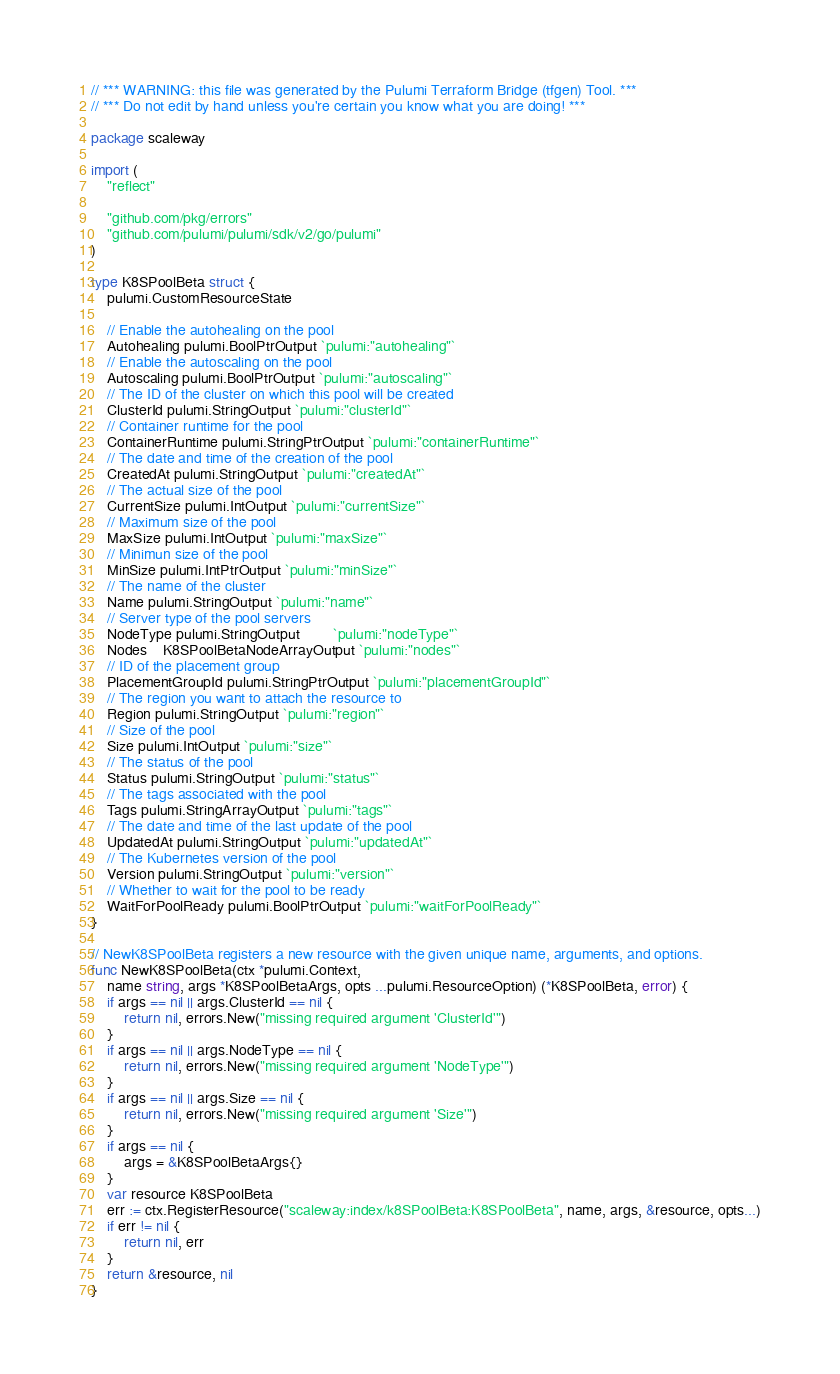Convert code to text. <code><loc_0><loc_0><loc_500><loc_500><_Go_>// *** WARNING: this file was generated by the Pulumi Terraform Bridge (tfgen) Tool. ***
// *** Do not edit by hand unless you're certain you know what you are doing! ***

package scaleway

import (
	"reflect"

	"github.com/pkg/errors"
	"github.com/pulumi/pulumi/sdk/v2/go/pulumi"
)

type K8SPoolBeta struct {
	pulumi.CustomResourceState

	// Enable the autohealing on the pool
	Autohealing pulumi.BoolPtrOutput `pulumi:"autohealing"`
	// Enable the autoscaling on the pool
	Autoscaling pulumi.BoolPtrOutput `pulumi:"autoscaling"`
	// The ID of the cluster on which this pool will be created
	ClusterId pulumi.StringOutput `pulumi:"clusterId"`
	// Container runtime for the pool
	ContainerRuntime pulumi.StringPtrOutput `pulumi:"containerRuntime"`
	// The date and time of the creation of the pool
	CreatedAt pulumi.StringOutput `pulumi:"createdAt"`
	// The actual size of the pool
	CurrentSize pulumi.IntOutput `pulumi:"currentSize"`
	// Maximum size of the pool
	MaxSize pulumi.IntOutput `pulumi:"maxSize"`
	// Minimun size of the pool
	MinSize pulumi.IntPtrOutput `pulumi:"minSize"`
	// The name of the cluster
	Name pulumi.StringOutput `pulumi:"name"`
	// Server type of the pool servers
	NodeType pulumi.StringOutput        `pulumi:"nodeType"`
	Nodes    K8SPoolBetaNodeArrayOutput `pulumi:"nodes"`
	// ID of the placement group
	PlacementGroupId pulumi.StringPtrOutput `pulumi:"placementGroupId"`
	// The region you want to attach the resource to
	Region pulumi.StringOutput `pulumi:"region"`
	// Size of the pool
	Size pulumi.IntOutput `pulumi:"size"`
	// The status of the pool
	Status pulumi.StringOutput `pulumi:"status"`
	// The tags associated with the pool
	Tags pulumi.StringArrayOutput `pulumi:"tags"`
	// The date and time of the last update of the pool
	UpdatedAt pulumi.StringOutput `pulumi:"updatedAt"`
	// The Kubernetes version of the pool
	Version pulumi.StringOutput `pulumi:"version"`
	// Whether to wait for the pool to be ready
	WaitForPoolReady pulumi.BoolPtrOutput `pulumi:"waitForPoolReady"`
}

// NewK8SPoolBeta registers a new resource with the given unique name, arguments, and options.
func NewK8SPoolBeta(ctx *pulumi.Context,
	name string, args *K8SPoolBetaArgs, opts ...pulumi.ResourceOption) (*K8SPoolBeta, error) {
	if args == nil || args.ClusterId == nil {
		return nil, errors.New("missing required argument 'ClusterId'")
	}
	if args == nil || args.NodeType == nil {
		return nil, errors.New("missing required argument 'NodeType'")
	}
	if args == nil || args.Size == nil {
		return nil, errors.New("missing required argument 'Size'")
	}
	if args == nil {
		args = &K8SPoolBetaArgs{}
	}
	var resource K8SPoolBeta
	err := ctx.RegisterResource("scaleway:index/k8SPoolBeta:K8SPoolBeta", name, args, &resource, opts...)
	if err != nil {
		return nil, err
	}
	return &resource, nil
}
</code> 